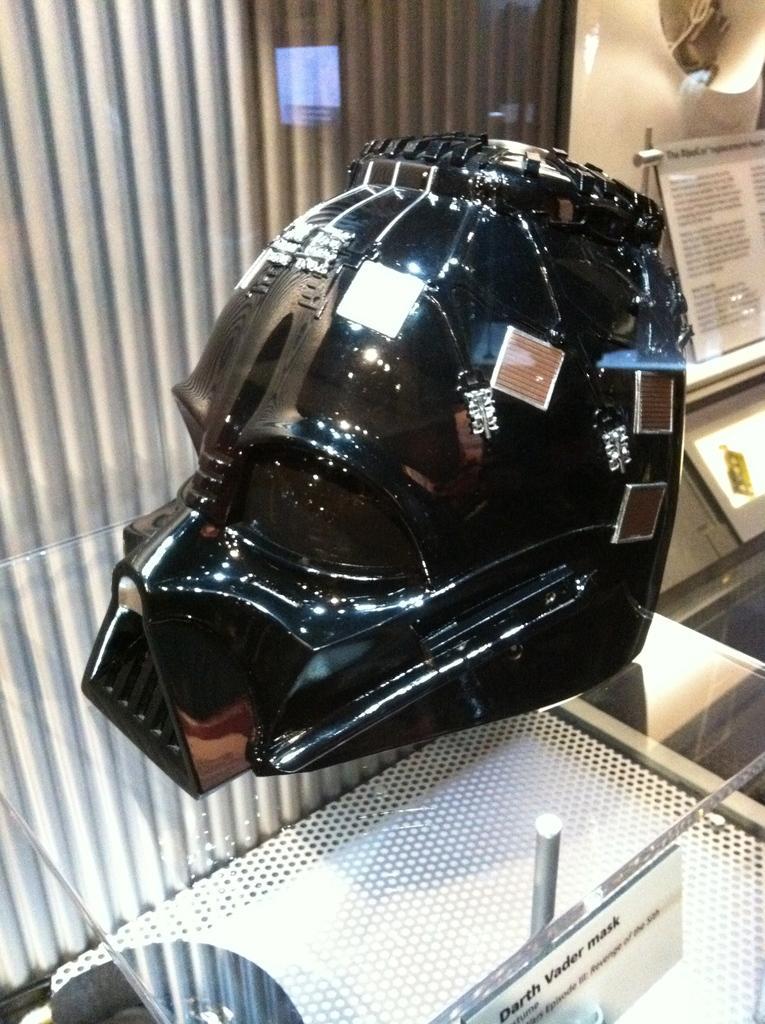Please provide a concise description of this image. There is a black object on a glass. There is a note at the back. 